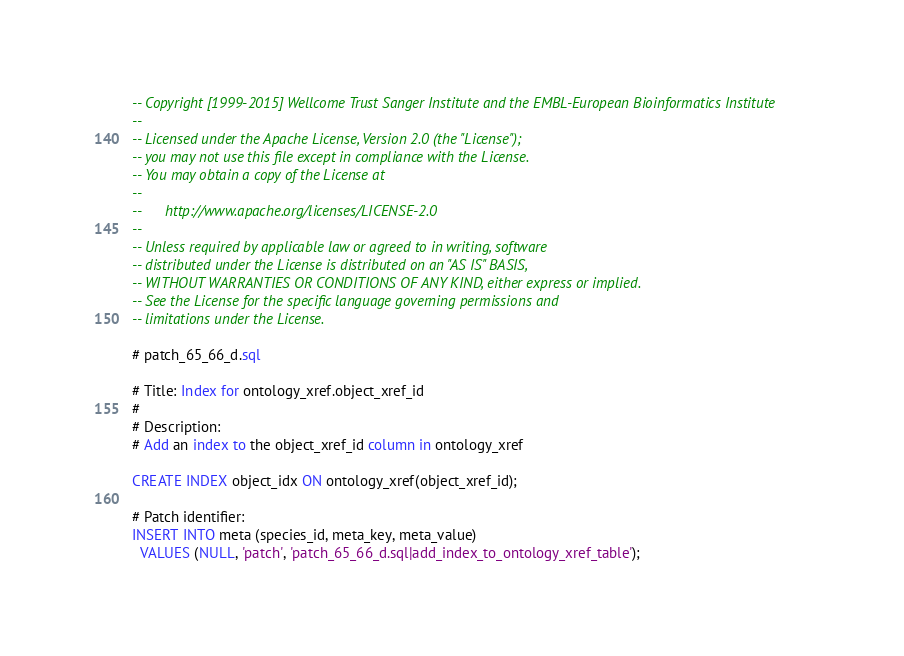<code> <loc_0><loc_0><loc_500><loc_500><_SQL_>-- Copyright [1999-2015] Wellcome Trust Sanger Institute and the EMBL-European Bioinformatics Institute
-- 
-- Licensed under the Apache License, Version 2.0 (the "License");
-- you may not use this file except in compliance with the License.
-- You may obtain a copy of the License at
-- 
--      http://www.apache.org/licenses/LICENSE-2.0
-- 
-- Unless required by applicable law or agreed to in writing, software
-- distributed under the License is distributed on an "AS IS" BASIS,
-- WITHOUT WARRANTIES OR CONDITIONS OF ANY KIND, either express or implied.
-- See the License for the specific language governing permissions and
-- limitations under the License.

# patch_65_66_d.sql

# Title: Index for ontology_xref.object_xref_id
#
# Description:
# Add an index to the object_xref_id column in ontology_xref

CREATE INDEX object_idx ON ontology_xref(object_xref_id);

# Patch identifier:
INSERT INTO meta (species_id, meta_key, meta_value)
  VALUES (NULL, 'patch', 'patch_65_66_d.sql|add_index_to_ontology_xref_table');
</code> 